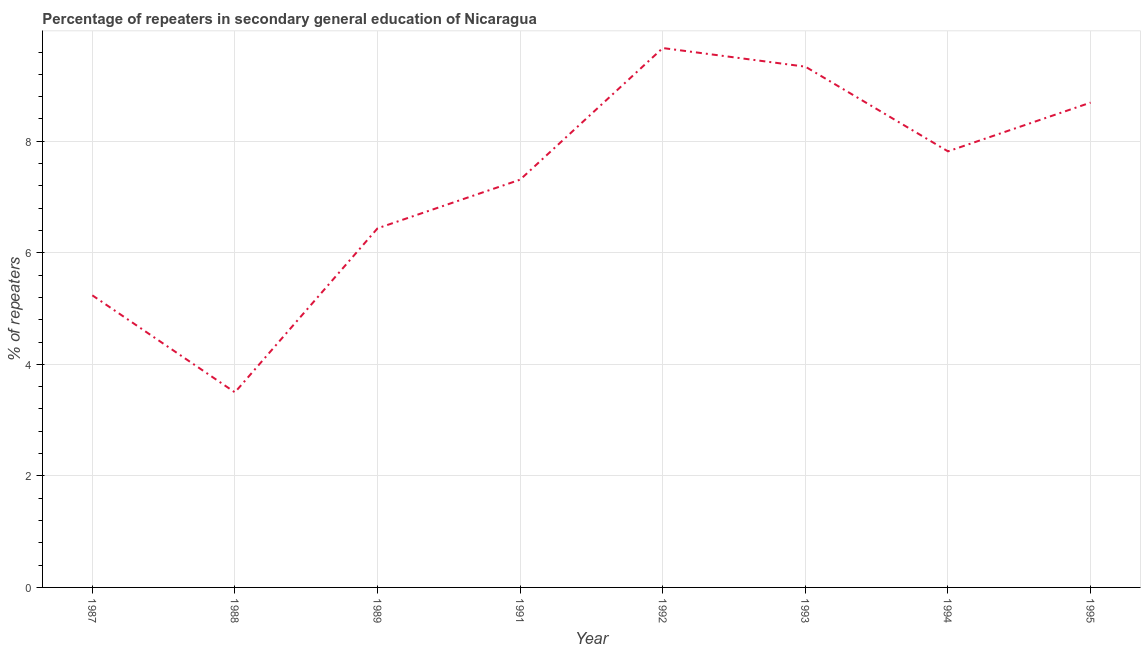What is the percentage of repeaters in 1989?
Give a very brief answer. 6.44. Across all years, what is the maximum percentage of repeaters?
Make the answer very short. 9.67. Across all years, what is the minimum percentage of repeaters?
Keep it short and to the point. 3.5. What is the sum of the percentage of repeaters?
Your answer should be very brief. 58.01. What is the difference between the percentage of repeaters in 1988 and 1994?
Your answer should be compact. -4.32. What is the average percentage of repeaters per year?
Give a very brief answer. 7.25. What is the median percentage of repeaters?
Make the answer very short. 7.57. In how many years, is the percentage of repeaters greater than 4.4 %?
Your response must be concise. 7. Do a majority of the years between 1992 and 1988 (inclusive) have percentage of repeaters greater than 8.4 %?
Your response must be concise. Yes. What is the ratio of the percentage of repeaters in 1991 to that in 1992?
Give a very brief answer. 0.76. Is the difference between the percentage of repeaters in 1992 and 1995 greater than the difference between any two years?
Offer a very short reply. No. What is the difference between the highest and the second highest percentage of repeaters?
Ensure brevity in your answer.  0.33. Is the sum of the percentage of repeaters in 1991 and 1995 greater than the maximum percentage of repeaters across all years?
Your response must be concise. Yes. What is the difference between the highest and the lowest percentage of repeaters?
Your answer should be very brief. 6.17. How many lines are there?
Make the answer very short. 1. How many years are there in the graph?
Give a very brief answer. 8. What is the difference between two consecutive major ticks on the Y-axis?
Offer a terse response. 2. Are the values on the major ticks of Y-axis written in scientific E-notation?
Make the answer very short. No. Does the graph contain grids?
Keep it short and to the point. Yes. What is the title of the graph?
Provide a short and direct response. Percentage of repeaters in secondary general education of Nicaragua. What is the label or title of the X-axis?
Provide a succinct answer. Year. What is the label or title of the Y-axis?
Your response must be concise. % of repeaters. What is the % of repeaters of 1987?
Offer a terse response. 5.24. What is the % of repeaters in 1988?
Offer a very short reply. 3.5. What is the % of repeaters in 1989?
Give a very brief answer. 6.44. What is the % of repeaters in 1991?
Keep it short and to the point. 7.31. What is the % of repeaters of 1992?
Your response must be concise. 9.67. What is the % of repeaters of 1993?
Make the answer very short. 9.34. What is the % of repeaters of 1994?
Provide a short and direct response. 7.82. What is the % of repeaters of 1995?
Ensure brevity in your answer.  8.69. What is the difference between the % of repeaters in 1987 and 1988?
Ensure brevity in your answer.  1.74. What is the difference between the % of repeaters in 1987 and 1989?
Your answer should be very brief. -1.2. What is the difference between the % of repeaters in 1987 and 1991?
Offer a very short reply. -2.07. What is the difference between the % of repeaters in 1987 and 1992?
Your response must be concise. -4.43. What is the difference between the % of repeaters in 1987 and 1993?
Give a very brief answer. -4.1. What is the difference between the % of repeaters in 1987 and 1994?
Your answer should be compact. -2.58. What is the difference between the % of repeaters in 1987 and 1995?
Provide a short and direct response. -3.46. What is the difference between the % of repeaters in 1988 and 1989?
Offer a terse response. -2.94. What is the difference between the % of repeaters in 1988 and 1991?
Your answer should be very brief. -3.81. What is the difference between the % of repeaters in 1988 and 1992?
Provide a succinct answer. -6.17. What is the difference between the % of repeaters in 1988 and 1993?
Your response must be concise. -5.84. What is the difference between the % of repeaters in 1988 and 1994?
Provide a short and direct response. -4.32. What is the difference between the % of repeaters in 1988 and 1995?
Keep it short and to the point. -5.2. What is the difference between the % of repeaters in 1989 and 1991?
Your answer should be very brief. -0.87. What is the difference between the % of repeaters in 1989 and 1992?
Offer a terse response. -3.23. What is the difference between the % of repeaters in 1989 and 1993?
Your answer should be compact. -2.9. What is the difference between the % of repeaters in 1989 and 1994?
Your answer should be very brief. -1.38. What is the difference between the % of repeaters in 1989 and 1995?
Offer a terse response. -2.25. What is the difference between the % of repeaters in 1991 and 1992?
Provide a succinct answer. -2.36. What is the difference between the % of repeaters in 1991 and 1993?
Keep it short and to the point. -2.03. What is the difference between the % of repeaters in 1991 and 1994?
Offer a terse response. -0.51. What is the difference between the % of repeaters in 1991 and 1995?
Offer a terse response. -1.38. What is the difference between the % of repeaters in 1992 and 1993?
Ensure brevity in your answer.  0.33. What is the difference between the % of repeaters in 1992 and 1994?
Your response must be concise. 1.85. What is the difference between the % of repeaters in 1992 and 1995?
Your response must be concise. 0.98. What is the difference between the % of repeaters in 1993 and 1994?
Offer a terse response. 1.52. What is the difference between the % of repeaters in 1993 and 1995?
Your answer should be very brief. 0.64. What is the difference between the % of repeaters in 1994 and 1995?
Provide a short and direct response. -0.87. What is the ratio of the % of repeaters in 1987 to that in 1988?
Your answer should be compact. 1.5. What is the ratio of the % of repeaters in 1987 to that in 1989?
Your response must be concise. 0.81. What is the ratio of the % of repeaters in 1987 to that in 1991?
Your answer should be compact. 0.72. What is the ratio of the % of repeaters in 1987 to that in 1992?
Your response must be concise. 0.54. What is the ratio of the % of repeaters in 1987 to that in 1993?
Give a very brief answer. 0.56. What is the ratio of the % of repeaters in 1987 to that in 1994?
Provide a short and direct response. 0.67. What is the ratio of the % of repeaters in 1987 to that in 1995?
Offer a very short reply. 0.6. What is the ratio of the % of repeaters in 1988 to that in 1989?
Keep it short and to the point. 0.54. What is the ratio of the % of repeaters in 1988 to that in 1991?
Provide a succinct answer. 0.48. What is the ratio of the % of repeaters in 1988 to that in 1992?
Your answer should be compact. 0.36. What is the ratio of the % of repeaters in 1988 to that in 1993?
Keep it short and to the point. 0.38. What is the ratio of the % of repeaters in 1988 to that in 1994?
Keep it short and to the point. 0.45. What is the ratio of the % of repeaters in 1988 to that in 1995?
Give a very brief answer. 0.4. What is the ratio of the % of repeaters in 1989 to that in 1991?
Your answer should be very brief. 0.88. What is the ratio of the % of repeaters in 1989 to that in 1992?
Offer a terse response. 0.67. What is the ratio of the % of repeaters in 1989 to that in 1993?
Offer a very short reply. 0.69. What is the ratio of the % of repeaters in 1989 to that in 1994?
Provide a short and direct response. 0.82. What is the ratio of the % of repeaters in 1989 to that in 1995?
Make the answer very short. 0.74. What is the ratio of the % of repeaters in 1991 to that in 1992?
Make the answer very short. 0.76. What is the ratio of the % of repeaters in 1991 to that in 1993?
Your answer should be compact. 0.78. What is the ratio of the % of repeaters in 1991 to that in 1994?
Offer a terse response. 0.94. What is the ratio of the % of repeaters in 1991 to that in 1995?
Keep it short and to the point. 0.84. What is the ratio of the % of repeaters in 1992 to that in 1993?
Offer a very short reply. 1.04. What is the ratio of the % of repeaters in 1992 to that in 1994?
Provide a short and direct response. 1.24. What is the ratio of the % of repeaters in 1992 to that in 1995?
Provide a succinct answer. 1.11. What is the ratio of the % of repeaters in 1993 to that in 1994?
Ensure brevity in your answer.  1.19. What is the ratio of the % of repeaters in 1993 to that in 1995?
Your answer should be very brief. 1.07. What is the ratio of the % of repeaters in 1994 to that in 1995?
Make the answer very short. 0.9. 